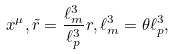<formula> <loc_0><loc_0><loc_500><loc_500>x ^ { \mu } , \tilde { r } = \frac { \ell _ { m } ^ { 3 } } { \ell _ { p } ^ { 3 } } r , \ell _ { m } ^ { 3 } = \theta \ell _ { p } ^ { 3 } ,</formula> 